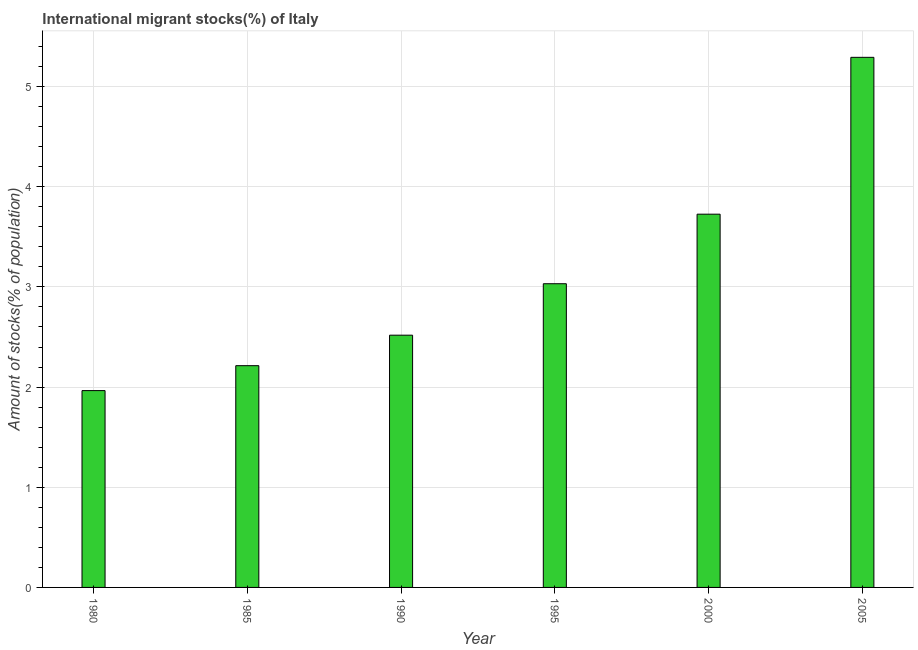Does the graph contain any zero values?
Give a very brief answer. No. What is the title of the graph?
Provide a succinct answer. International migrant stocks(%) of Italy. What is the label or title of the Y-axis?
Offer a very short reply. Amount of stocks(% of population). What is the number of international migrant stocks in 2005?
Keep it short and to the point. 5.29. Across all years, what is the maximum number of international migrant stocks?
Your answer should be very brief. 5.29. Across all years, what is the minimum number of international migrant stocks?
Provide a succinct answer. 1.96. In which year was the number of international migrant stocks minimum?
Give a very brief answer. 1980. What is the sum of the number of international migrant stocks?
Offer a terse response. 18.75. What is the difference between the number of international migrant stocks in 1980 and 2000?
Provide a short and direct response. -1.76. What is the average number of international migrant stocks per year?
Provide a succinct answer. 3.12. What is the median number of international migrant stocks?
Give a very brief answer. 2.77. Do a majority of the years between 2000 and 1980 (inclusive) have number of international migrant stocks greater than 3.2 %?
Provide a short and direct response. Yes. What is the ratio of the number of international migrant stocks in 1980 to that in 2000?
Make the answer very short. 0.53. Is the number of international migrant stocks in 2000 less than that in 2005?
Your answer should be compact. Yes. Is the difference between the number of international migrant stocks in 1980 and 1990 greater than the difference between any two years?
Ensure brevity in your answer.  No. What is the difference between the highest and the second highest number of international migrant stocks?
Your answer should be very brief. 1.57. Is the sum of the number of international migrant stocks in 1990 and 2000 greater than the maximum number of international migrant stocks across all years?
Your answer should be very brief. Yes. What is the difference between the highest and the lowest number of international migrant stocks?
Offer a very short reply. 3.33. In how many years, is the number of international migrant stocks greater than the average number of international migrant stocks taken over all years?
Offer a terse response. 2. How many bars are there?
Provide a short and direct response. 6. How many years are there in the graph?
Your response must be concise. 6. What is the Amount of stocks(% of population) in 1980?
Offer a very short reply. 1.96. What is the Amount of stocks(% of population) of 1985?
Your answer should be very brief. 2.21. What is the Amount of stocks(% of population) of 1990?
Your answer should be very brief. 2.52. What is the Amount of stocks(% of population) of 1995?
Make the answer very short. 3.03. What is the Amount of stocks(% of population) in 2000?
Offer a very short reply. 3.73. What is the Amount of stocks(% of population) in 2005?
Offer a very short reply. 5.29. What is the difference between the Amount of stocks(% of population) in 1980 and 1985?
Your response must be concise. -0.25. What is the difference between the Amount of stocks(% of population) in 1980 and 1990?
Keep it short and to the point. -0.55. What is the difference between the Amount of stocks(% of population) in 1980 and 1995?
Provide a short and direct response. -1.07. What is the difference between the Amount of stocks(% of population) in 1980 and 2000?
Provide a short and direct response. -1.76. What is the difference between the Amount of stocks(% of population) in 1980 and 2005?
Ensure brevity in your answer.  -3.33. What is the difference between the Amount of stocks(% of population) in 1985 and 1990?
Ensure brevity in your answer.  -0.3. What is the difference between the Amount of stocks(% of population) in 1985 and 1995?
Your answer should be compact. -0.82. What is the difference between the Amount of stocks(% of population) in 1985 and 2000?
Offer a terse response. -1.51. What is the difference between the Amount of stocks(% of population) in 1985 and 2005?
Your response must be concise. -3.08. What is the difference between the Amount of stocks(% of population) in 1990 and 1995?
Offer a very short reply. -0.51. What is the difference between the Amount of stocks(% of population) in 1990 and 2000?
Provide a succinct answer. -1.21. What is the difference between the Amount of stocks(% of population) in 1990 and 2005?
Keep it short and to the point. -2.77. What is the difference between the Amount of stocks(% of population) in 1995 and 2000?
Offer a very short reply. -0.69. What is the difference between the Amount of stocks(% of population) in 1995 and 2005?
Your response must be concise. -2.26. What is the difference between the Amount of stocks(% of population) in 2000 and 2005?
Your answer should be very brief. -1.57. What is the ratio of the Amount of stocks(% of population) in 1980 to that in 1985?
Your answer should be very brief. 0.89. What is the ratio of the Amount of stocks(% of population) in 1980 to that in 1990?
Your response must be concise. 0.78. What is the ratio of the Amount of stocks(% of population) in 1980 to that in 1995?
Offer a terse response. 0.65. What is the ratio of the Amount of stocks(% of population) in 1980 to that in 2000?
Offer a very short reply. 0.53. What is the ratio of the Amount of stocks(% of population) in 1980 to that in 2005?
Your answer should be very brief. 0.37. What is the ratio of the Amount of stocks(% of population) in 1985 to that in 1990?
Give a very brief answer. 0.88. What is the ratio of the Amount of stocks(% of population) in 1985 to that in 1995?
Provide a succinct answer. 0.73. What is the ratio of the Amount of stocks(% of population) in 1985 to that in 2000?
Your answer should be compact. 0.59. What is the ratio of the Amount of stocks(% of population) in 1985 to that in 2005?
Keep it short and to the point. 0.42. What is the ratio of the Amount of stocks(% of population) in 1990 to that in 1995?
Give a very brief answer. 0.83. What is the ratio of the Amount of stocks(% of population) in 1990 to that in 2000?
Provide a succinct answer. 0.68. What is the ratio of the Amount of stocks(% of population) in 1990 to that in 2005?
Offer a very short reply. 0.48. What is the ratio of the Amount of stocks(% of population) in 1995 to that in 2000?
Offer a terse response. 0.81. What is the ratio of the Amount of stocks(% of population) in 1995 to that in 2005?
Keep it short and to the point. 0.57. What is the ratio of the Amount of stocks(% of population) in 2000 to that in 2005?
Your response must be concise. 0.7. 